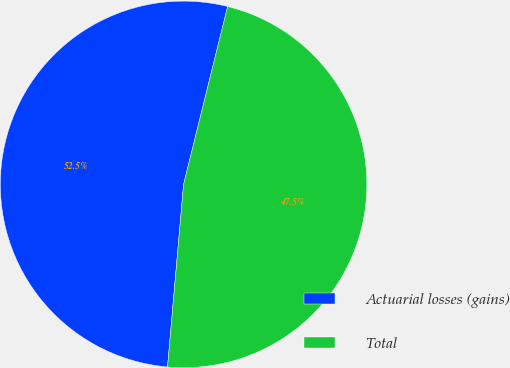Convert chart. <chart><loc_0><loc_0><loc_500><loc_500><pie_chart><fcel>Actuarial losses (gains)<fcel>Total<nl><fcel>52.47%<fcel>47.53%<nl></chart> 